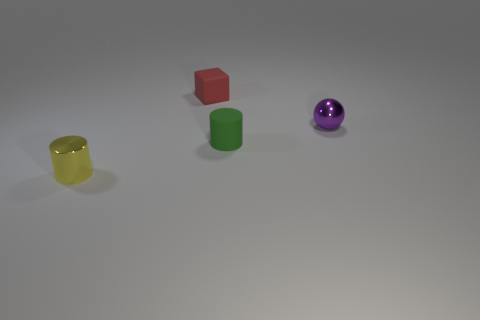Does the block have the same color as the metallic cylinder?
Provide a succinct answer. No. Is the number of small cubes greater than the number of yellow matte objects?
Give a very brief answer. Yes. How many other objects are the same color as the tiny metallic sphere?
Keep it short and to the point. 0. There is a small metal thing that is in front of the sphere; what number of tiny objects are right of it?
Provide a short and direct response. 3. Are there any small green cylinders right of the purple ball?
Offer a very short reply. No. There is a object that is left of the rubber object that is behind the purple metal sphere; what is its shape?
Offer a terse response. Cylinder. Is the number of small green objects behind the tiny rubber block less than the number of tiny purple metal things that are in front of the small purple shiny ball?
Your answer should be compact. No. The other shiny thing that is the same shape as the small green object is what color?
Provide a short and direct response. Yellow. How many cylinders are left of the small green rubber cylinder and behind the small yellow thing?
Give a very brief answer. 0. Are there more small red rubber blocks in front of the tiny green matte cylinder than tiny red rubber cubes left of the tiny red thing?
Provide a succinct answer. No. 